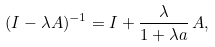Convert formula to latex. <formula><loc_0><loc_0><loc_500><loc_500>( I - \lambda A ) ^ { - 1 } = I + \frac { \lambda } { 1 + \lambda a } \, A ,</formula> 